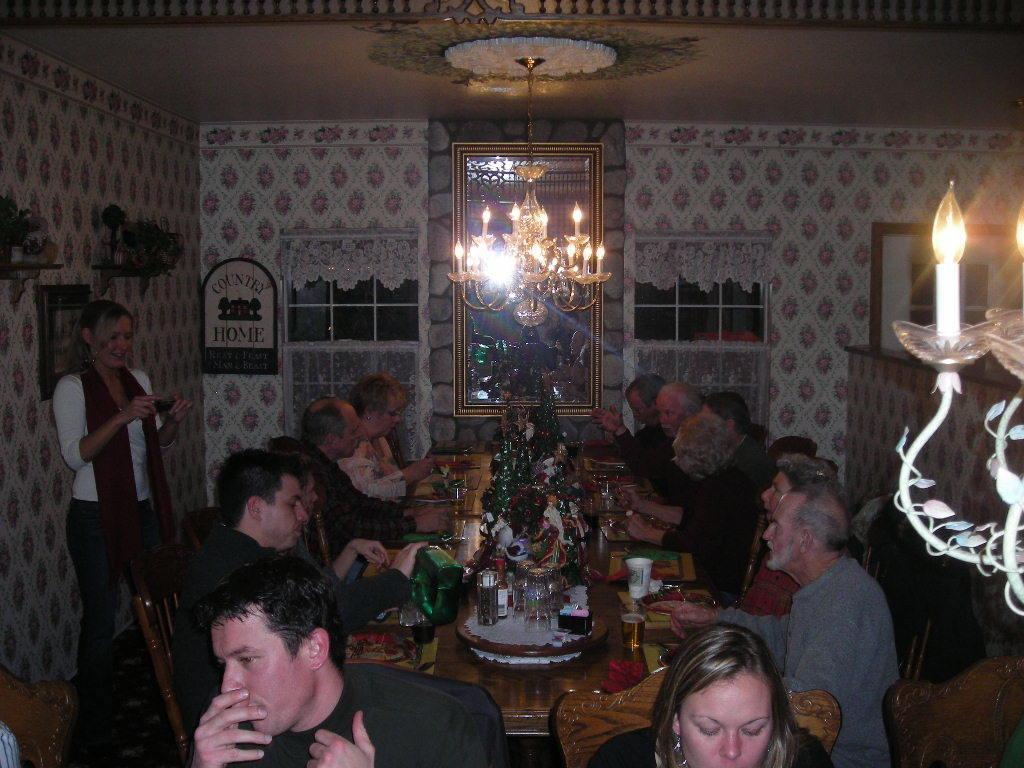Can you describe this image briefly? In this picture we can see some people are sitting on the chairs around the table. On the table there are some bottles and glasses. Here one person is standing and taking a snap of them. And on the background there is a wall. This is the ceiling light. And there is a candle. 